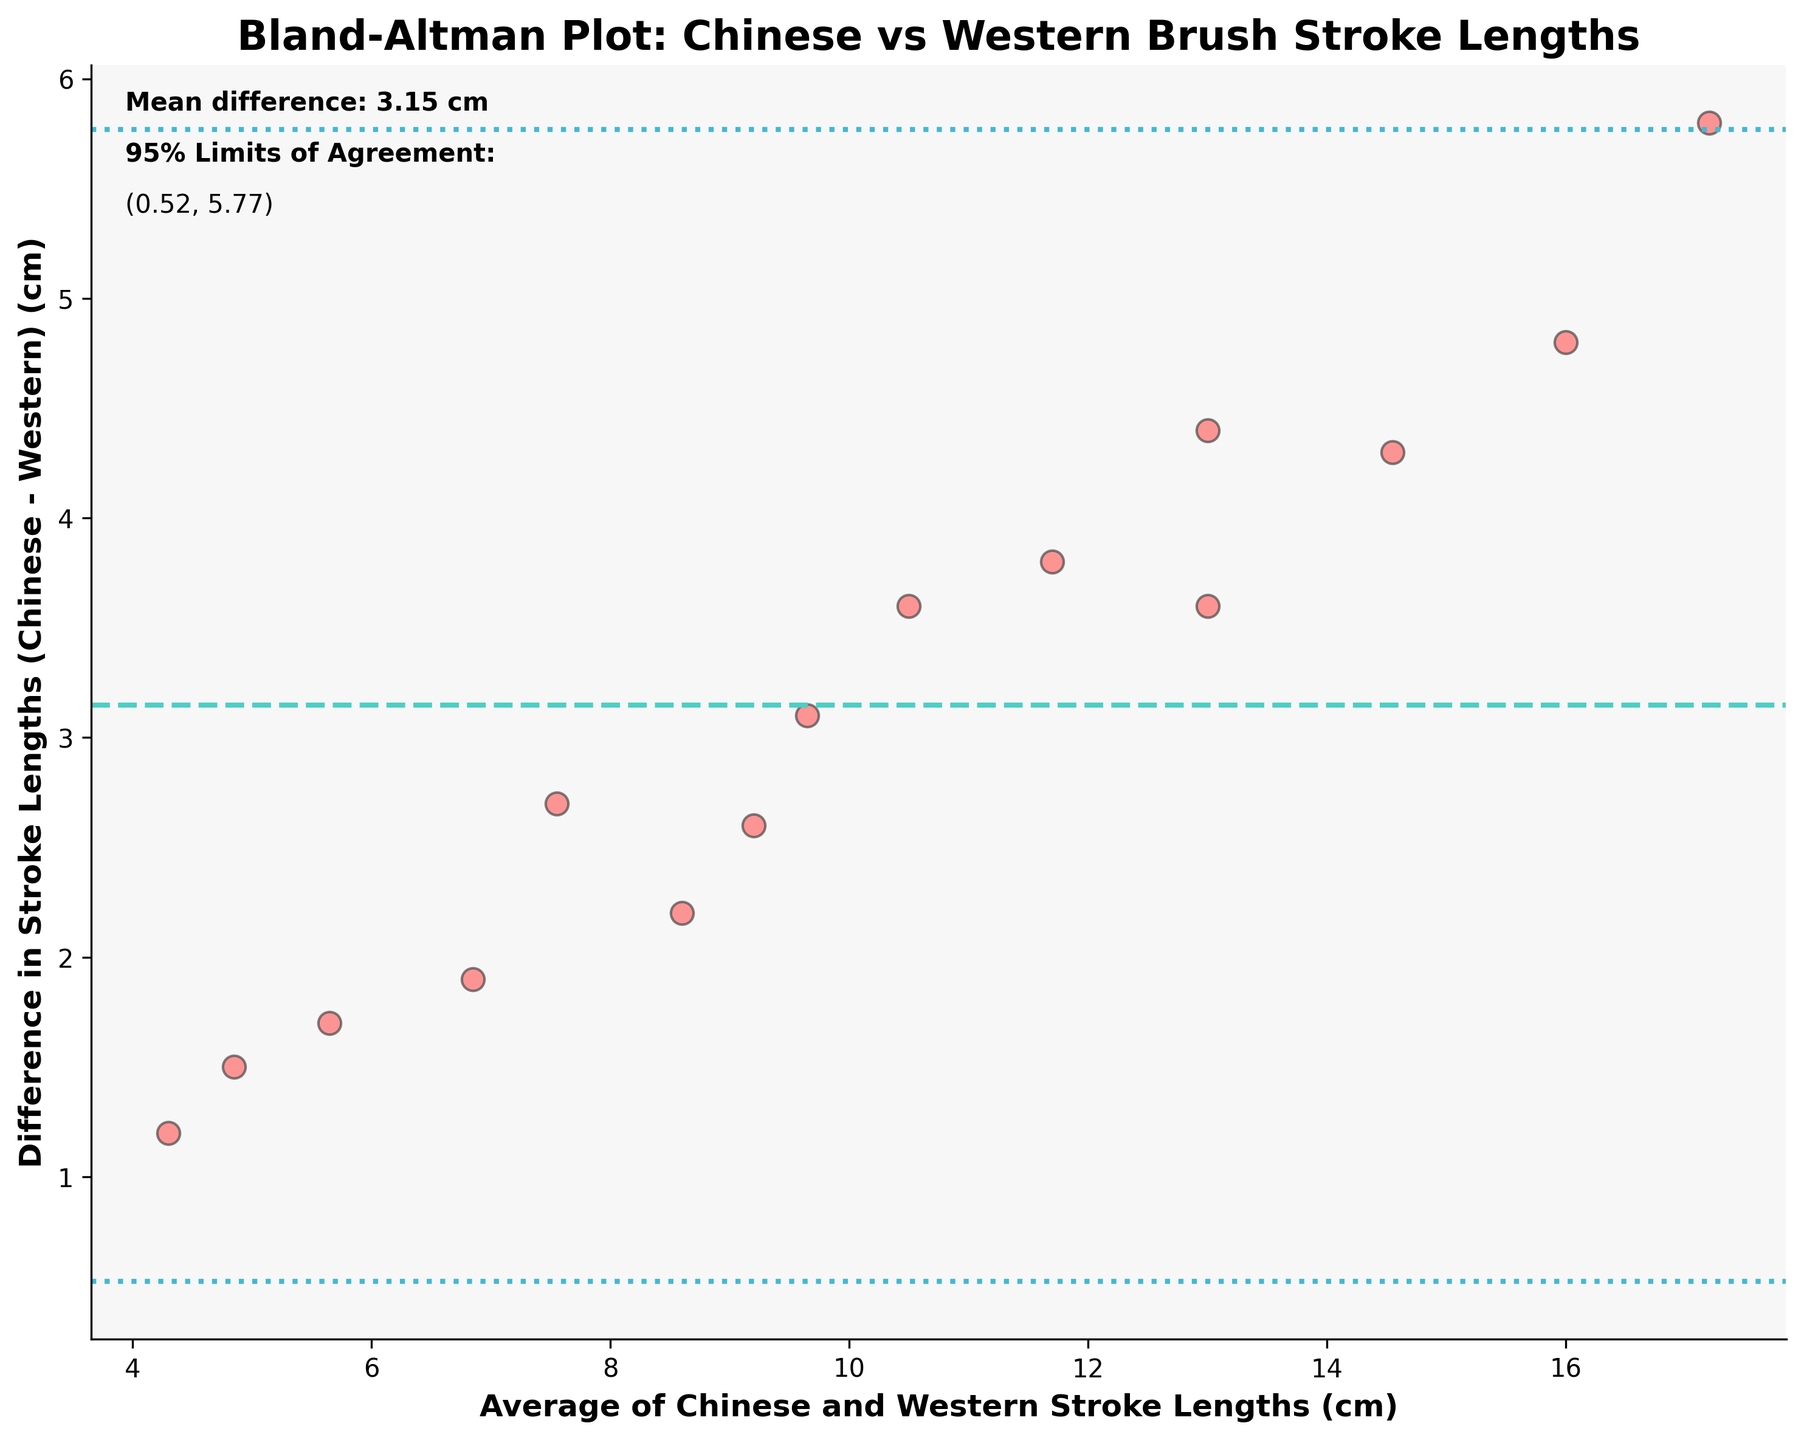what is the title of the figure? The title is typically located at the top of the figure and provides brief information about the content. It reads: "Bland-Altman Plot: Chinese vs Western Brush Stroke Lengths."
Answer: Bland-Altman Plot: Chinese vs Western Brush Stroke Lengths what is plotted on the x-axis? The x-axis is labeled, indicating what data it represents. It reads: "Average of Chinese and Western Stroke Lengths (cm)."
Answer: Average of Chinese and Western Stroke Lengths (cm) how many data points are there in the plot? To determine the number of data points, one can count the individual scatter points displayed in the plot.
Answer: 15 what is the mean difference in stroke lengths between Chinese and Western artworks? The mean difference is explicitly mentioned within the figure. The text box states: "Mean difference: 3.37 cm."
Answer: 3.37 cm what are the 95% limits of agreement? The 95% limits of agreement are displayed as text in the figure, and the corresponding horizontal dashed lines on the plot illustrate this range. It reads: "95% Limits of Agreement: (-0.36, 7.10)."
Answer: (-0.36, 7.10) what information can be derived from the mean difference value? The mean difference indicates the average discrepancy between stroke lengths in Chinese and Western paintings, suggesting that Chinese stroke lengths tend to be longer by an average of 3.37 cm.
Answer: Chinese strokes are on average 3.37 cm longer what do the two horizontal dashed lines represent? These lines indicate the 95% limits of agreement, which show the range within most differences between paired measurements are expected to lie. This interval is from -0.36 cm to 7.10 cm.
Answer: 95% limits of agreement how do you interpret points falling outside the 95% limits of agreement? Points outside the limits suggest that the difference between those specific pairs of measurements is greater than expected, indicating potential outliers or a significant disagreement.
Answer: Indicate outliers or significant disagreement which painting has the largest positive difference in stroke lengths? By examining the vertical distance from the x-axis to the higher end, "Waterfall" shows the largest positive difference, as it is the furthest above the mean difference line.
Answer: Waterfall which painting has the smallest difference in stroke lengths? The painting closest to the mean difference line represents the smallest difference. "Chrysanthemums" appears to be the closest to this line.
Answer: Chrysanthemums 